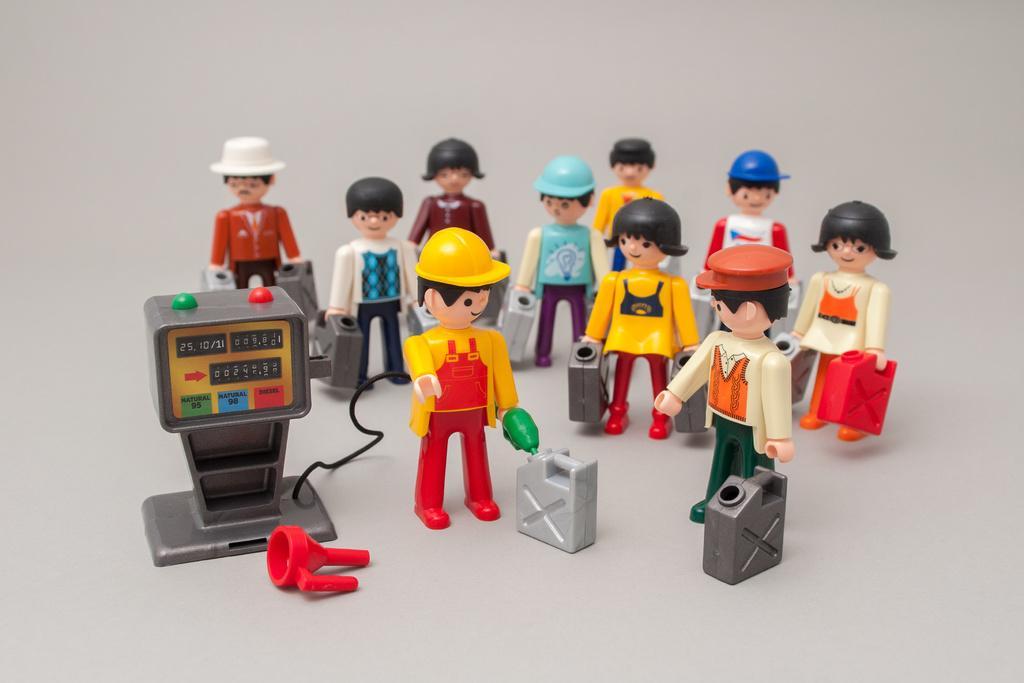How would you summarize this image in a sentence or two? Here we can see toys on this white surface. 